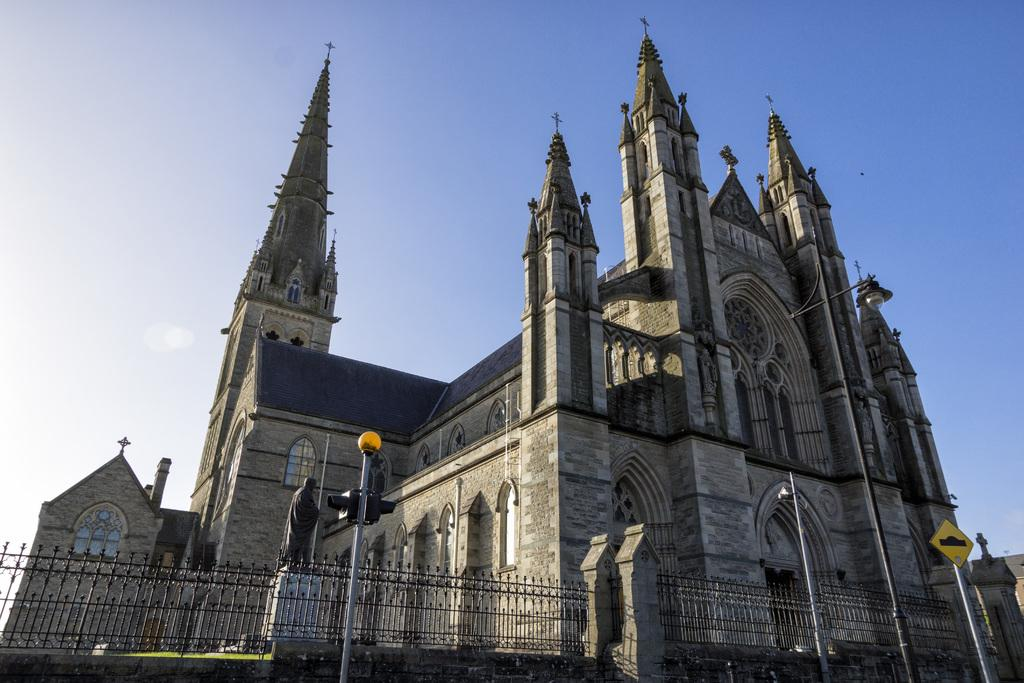What structure is the main focus of the image? There is a building in the image. What is located in front of the building? There is a sign board and a traffic signal in front of the building. What can be seen in the background of the image? The sky is visible in the background of the image. How many people are walking downtown in the image? There are no people or downtown area mentioned in the image; it only features a building, a sign board, a traffic signal, and the sky. What type of insect can be seen flying near the traffic signal in the image? There are no insects present in the image. 